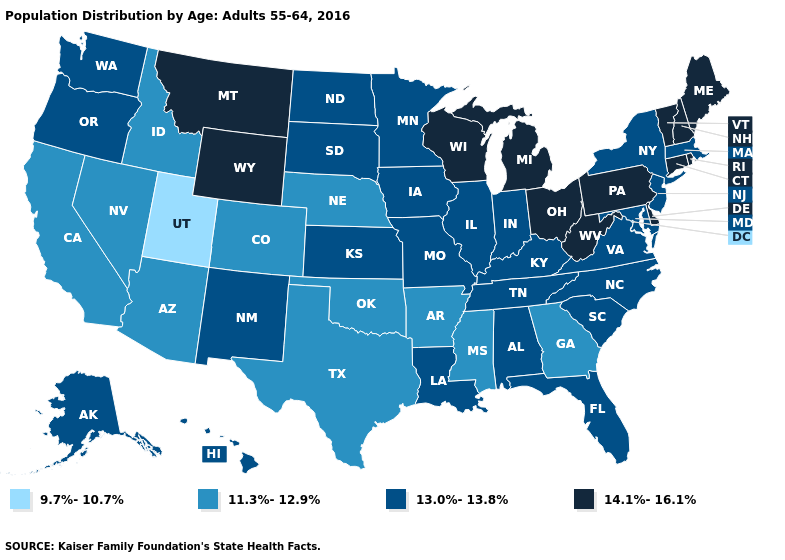Name the states that have a value in the range 13.0%-13.8%?
Be succinct. Alabama, Alaska, Florida, Hawaii, Illinois, Indiana, Iowa, Kansas, Kentucky, Louisiana, Maryland, Massachusetts, Minnesota, Missouri, New Jersey, New Mexico, New York, North Carolina, North Dakota, Oregon, South Carolina, South Dakota, Tennessee, Virginia, Washington. What is the lowest value in states that border New Jersey?
Keep it brief. 13.0%-13.8%. What is the lowest value in the USA?
Write a very short answer. 9.7%-10.7%. Which states have the highest value in the USA?
Short answer required. Connecticut, Delaware, Maine, Michigan, Montana, New Hampshire, Ohio, Pennsylvania, Rhode Island, Vermont, West Virginia, Wisconsin, Wyoming. Name the states that have a value in the range 9.7%-10.7%?
Keep it brief. Utah. What is the highest value in the West ?
Keep it brief. 14.1%-16.1%. What is the highest value in states that border West Virginia?
Be succinct. 14.1%-16.1%. What is the lowest value in the USA?
Quick response, please. 9.7%-10.7%. Does Texas have the highest value in the South?
Write a very short answer. No. What is the value of Alaska?
Write a very short answer. 13.0%-13.8%. Among the states that border Idaho , which have the lowest value?
Quick response, please. Utah. What is the value of Kentucky?
Answer briefly. 13.0%-13.8%. How many symbols are there in the legend?
Be succinct. 4. 